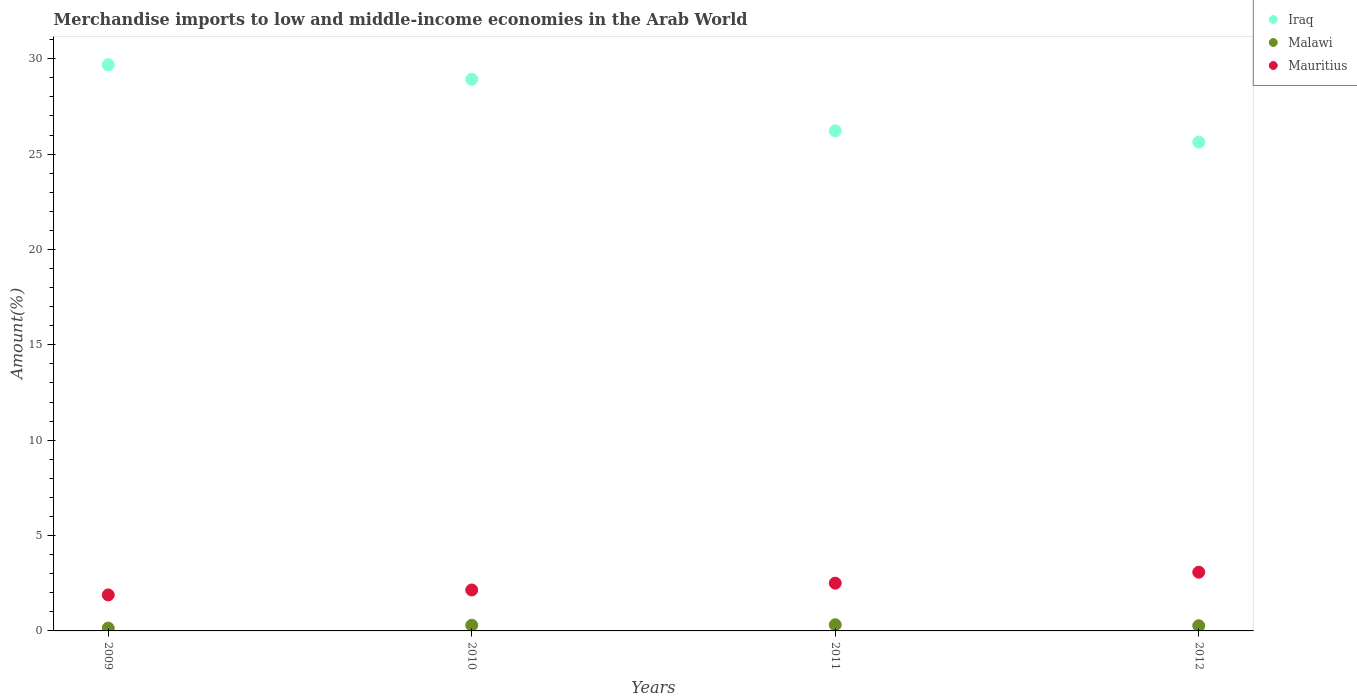Is the number of dotlines equal to the number of legend labels?
Make the answer very short. Yes. What is the percentage of amount earned from merchandise imports in Malawi in 2010?
Offer a very short reply. 0.3. Across all years, what is the maximum percentage of amount earned from merchandise imports in Mauritius?
Make the answer very short. 3.08. Across all years, what is the minimum percentage of amount earned from merchandise imports in Iraq?
Your response must be concise. 25.63. In which year was the percentage of amount earned from merchandise imports in Mauritius maximum?
Offer a very short reply. 2012. What is the total percentage of amount earned from merchandise imports in Malawi in the graph?
Your answer should be very brief. 1.04. What is the difference between the percentage of amount earned from merchandise imports in Malawi in 2009 and that in 2012?
Your response must be concise. -0.12. What is the difference between the percentage of amount earned from merchandise imports in Mauritius in 2011 and the percentage of amount earned from merchandise imports in Iraq in 2010?
Your answer should be compact. -26.41. What is the average percentage of amount earned from merchandise imports in Iraq per year?
Offer a very short reply. 27.61. In the year 2011, what is the difference between the percentage of amount earned from merchandise imports in Malawi and percentage of amount earned from merchandise imports in Iraq?
Your answer should be compact. -25.9. In how many years, is the percentage of amount earned from merchandise imports in Mauritius greater than 20 %?
Your answer should be very brief. 0. What is the ratio of the percentage of amount earned from merchandise imports in Malawi in 2011 to that in 2012?
Your response must be concise. 1.2. Is the percentage of amount earned from merchandise imports in Malawi in 2009 less than that in 2010?
Provide a short and direct response. Yes. What is the difference between the highest and the second highest percentage of amount earned from merchandise imports in Malawi?
Offer a very short reply. 0.03. What is the difference between the highest and the lowest percentage of amount earned from merchandise imports in Iraq?
Your answer should be compact. 4.05. Is the sum of the percentage of amount earned from merchandise imports in Mauritius in 2010 and 2011 greater than the maximum percentage of amount earned from merchandise imports in Iraq across all years?
Provide a succinct answer. No. Is it the case that in every year, the sum of the percentage of amount earned from merchandise imports in Iraq and percentage of amount earned from merchandise imports in Malawi  is greater than the percentage of amount earned from merchandise imports in Mauritius?
Your answer should be very brief. Yes. Does the percentage of amount earned from merchandise imports in Malawi monotonically increase over the years?
Make the answer very short. No. Is the percentage of amount earned from merchandise imports in Mauritius strictly greater than the percentage of amount earned from merchandise imports in Malawi over the years?
Your answer should be compact. Yes. Is the percentage of amount earned from merchandise imports in Iraq strictly less than the percentage of amount earned from merchandise imports in Malawi over the years?
Your answer should be very brief. No. How many years are there in the graph?
Keep it short and to the point. 4. What is the difference between two consecutive major ticks on the Y-axis?
Ensure brevity in your answer.  5. Are the values on the major ticks of Y-axis written in scientific E-notation?
Offer a very short reply. No. Does the graph contain any zero values?
Provide a short and direct response. No. Where does the legend appear in the graph?
Ensure brevity in your answer.  Top right. How many legend labels are there?
Keep it short and to the point. 3. What is the title of the graph?
Your response must be concise. Merchandise imports to low and middle-income economies in the Arab World. Does "Low income" appear as one of the legend labels in the graph?
Make the answer very short. No. What is the label or title of the X-axis?
Keep it short and to the point. Years. What is the label or title of the Y-axis?
Your answer should be compact. Amount(%). What is the Amount(%) of Iraq in 2009?
Your answer should be very brief. 29.68. What is the Amount(%) of Malawi in 2009?
Make the answer very short. 0.15. What is the Amount(%) in Mauritius in 2009?
Your answer should be compact. 1.89. What is the Amount(%) in Iraq in 2010?
Your answer should be very brief. 28.92. What is the Amount(%) in Malawi in 2010?
Ensure brevity in your answer.  0.3. What is the Amount(%) of Mauritius in 2010?
Offer a terse response. 2.15. What is the Amount(%) in Iraq in 2011?
Keep it short and to the point. 26.22. What is the Amount(%) of Malawi in 2011?
Keep it short and to the point. 0.32. What is the Amount(%) of Mauritius in 2011?
Ensure brevity in your answer.  2.5. What is the Amount(%) in Iraq in 2012?
Provide a short and direct response. 25.63. What is the Amount(%) in Malawi in 2012?
Offer a terse response. 0.27. What is the Amount(%) in Mauritius in 2012?
Ensure brevity in your answer.  3.08. Across all years, what is the maximum Amount(%) in Iraq?
Provide a succinct answer. 29.68. Across all years, what is the maximum Amount(%) in Malawi?
Your response must be concise. 0.32. Across all years, what is the maximum Amount(%) in Mauritius?
Your answer should be very brief. 3.08. Across all years, what is the minimum Amount(%) of Iraq?
Provide a succinct answer. 25.63. Across all years, what is the minimum Amount(%) in Malawi?
Ensure brevity in your answer.  0.15. Across all years, what is the minimum Amount(%) of Mauritius?
Provide a short and direct response. 1.89. What is the total Amount(%) in Iraq in the graph?
Offer a very short reply. 110.45. What is the total Amount(%) in Mauritius in the graph?
Provide a succinct answer. 9.62. What is the difference between the Amount(%) of Iraq in 2009 and that in 2010?
Your answer should be compact. 0.77. What is the difference between the Amount(%) of Malawi in 2009 and that in 2010?
Keep it short and to the point. -0.15. What is the difference between the Amount(%) of Mauritius in 2009 and that in 2010?
Your answer should be compact. -0.26. What is the difference between the Amount(%) of Iraq in 2009 and that in 2011?
Give a very brief answer. 3.46. What is the difference between the Amount(%) of Malawi in 2009 and that in 2011?
Provide a succinct answer. -0.18. What is the difference between the Amount(%) in Mauritius in 2009 and that in 2011?
Your answer should be compact. -0.62. What is the difference between the Amount(%) of Iraq in 2009 and that in 2012?
Your answer should be very brief. 4.05. What is the difference between the Amount(%) in Malawi in 2009 and that in 2012?
Offer a very short reply. -0.12. What is the difference between the Amount(%) in Mauritius in 2009 and that in 2012?
Offer a very short reply. -1.19. What is the difference between the Amount(%) of Iraq in 2010 and that in 2011?
Your response must be concise. 2.7. What is the difference between the Amount(%) of Malawi in 2010 and that in 2011?
Give a very brief answer. -0.03. What is the difference between the Amount(%) in Mauritius in 2010 and that in 2011?
Your answer should be very brief. -0.36. What is the difference between the Amount(%) of Iraq in 2010 and that in 2012?
Offer a very short reply. 3.29. What is the difference between the Amount(%) of Malawi in 2010 and that in 2012?
Provide a succinct answer. 0.03. What is the difference between the Amount(%) in Mauritius in 2010 and that in 2012?
Make the answer very short. -0.93. What is the difference between the Amount(%) of Iraq in 2011 and that in 2012?
Your response must be concise. 0.59. What is the difference between the Amount(%) in Malawi in 2011 and that in 2012?
Offer a terse response. 0.05. What is the difference between the Amount(%) of Mauritius in 2011 and that in 2012?
Ensure brevity in your answer.  -0.57. What is the difference between the Amount(%) of Iraq in 2009 and the Amount(%) of Malawi in 2010?
Your response must be concise. 29.39. What is the difference between the Amount(%) of Iraq in 2009 and the Amount(%) of Mauritius in 2010?
Offer a terse response. 27.54. What is the difference between the Amount(%) of Malawi in 2009 and the Amount(%) of Mauritius in 2010?
Give a very brief answer. -2. What is the difference between the Amount(%) in Iraq in 2009 and the Amount(%) in Malawi in 2011?
Your answer should be compact. 29.36. What is the difference between the Amount(%) in Iraq in 2009 and the Amount(%) in Mauritius in 2011?
Offer a very short reply. 27.18. What is the difference between the Amount(%) in Malawi in 2009 and the Amount(%) in Mauritius in 2011?
Ensure brevity in your answer.  -2.36. What is the difference between the Amount(%) in Iraq in 2009 and the Amount(%) in Malawi in 2012?
Your answer should be very brief. 29.41. What is the difference between the Amount(%) in Iraq in 2009 and the Amount(%) in Mauritius in 2012?
Offer a very short reply. 26.61. What is the difference between the Amount(%) in Malawi in 2009 and the Amount(%) in Mauritius in 2012?
Provide a short and direct response. -2.93. What is the difference between the Amount(%) of Iraq in 2010 and the Amount(%) of Malawi in 2011?
Your answer should be very brief. 28.59. What is the difference between the Amount(%) in Iraq in 2010 and the Amount(%) in Mauritius in 2011?
Keep it short and to the point. 26.41. What is the difference between the Amount(%) of Malawi in 2010 and the Amount(%) of Mauritius in 2011?
Your response must be concise. -2.21. What is the difference between the Amount(%) of Iraq in 2010 and the Amount(%) of Malawi in 2012?
Provide a succinct answer. 28.65. What is the difference between the Amount(%) of Iraq in 2010 and the Amount(%) of Mauritius in 2012?
Offer a very short reply. 25.84. What is the difference between the Amount(%) of Malawi in 2010 and the Amount(%) of Mauritius in 2012?
Your response must be concise. -2.78. What is the difference between the Amount(%) in Iraq in 2011 and the Amount(%) in Malawi in 2012?
Make the answer very short. 25.95. What is the difference between the Amount(%) of Iraq in 2011 and the Amount(%) of Mauritius in 2012?
Make the answer very short. 23.14. What is the difference between the Amount(%) in Malawi in 2011 and the Amount(%) in Mauritius in 2012?
Your answer should be very brief. -2.75. What is the average Amount(%) of Iraq per year?
Keep it short and to the point. 27.61. What is the average Amount(%) in Malawi per year?
Provide a short and direct response. 0.26. What is the average Amount(%) of Mauritius per year?
Offer a very short reply. 2.4. In the year 2009, what is the difference between the Amount(%) in Iraq and Amount(%) in Malawi?
Keep it short and to the point. 29.54. In the year 2009, what is the difference between the Amount(%) of Iraq and Amount(%) of Mauritius?
Provide a short and direct response. 27.8. In the year 2009, what is the difference between the Amount(%) in Malawi and Amount(%) in Mauritius?
Your response must be concise. -1.74. In the year 2010, what is the difference between the Amount(%) in Iraq and Amount(%) in Malawi?
Provide a succinct answer. 28.62. In the year 2010, what is the difference between the Amount(%) of Iraq and Amount(%) of Mauritius?
Your response must be concise. 26.77. In the year 2010, what is the difference between the Amount(%) in Malawi and Amount(%) in Mauritius?
Your answer should be very brief. -1.85. In the year 2011, what is the difference between the Amount(%) of Iraq and Amount(%) of Malawi?
Give a very brief answer. 25.9. In the year 2011, what is the difference between the Amount(%) of Iraq and Amount(%) of Mauritius?
Your answer should be compact. 23.72. In the year 2011, what is the difference between the Amount(%) in Malawi and Amount(%) in Mauritius?
Make the answer very short. -2.18. In the year 2012, what is the difference between the Amount(%) in Iraq and Amount(%) in Malawi?
Give a very brief answer. 25.36. In the year 2012, what is the difference between the Amount(%) of Iraq and Amount(%) of Mauritius?
Your answer should be compact. 22.55. In the year 2012, what is the difference between the Amount(%) of Malawi and Amount(%) of Mauritius?
Your response must be concise. -2.81. What is the ratio of the Amount(%) of Iraq in 2009 to that in 2010?
Your response must be concise. 1.03. What is the ratio of the Amount(%) of Malawi in 2009 to that in 2010?
Your answer should be compact. 0.5. What is the ratio of the Amount(%) of Mauritius in 2009 to that in 2010?
Your answer should be very brief. 0.88. What is the ratio of the Amount(%) in Iraq in 2009 to that in 2011?
Give a very brief answer. 1.13. What is the ratio of the Amount(%) of Malawi in 2009 to that in 2011?
Your answer should be very brief. 0.46. What is the ratio of the Amount(%) in Mauritius in 2009 to that in 2011?
Make the answer very short. 0.75. What is the ratio of the Amount(%) of Iraq in 2009 to that in 2012?
Your response must be concise. 1.16. What is the ratio of the Amount(%) of Malawi in 2009 to that in 2012?
Your answer should be very brief. 0.55. What is the ratio of the Amount(%) in Mauritius in 2009 to that in 2012?
Give a very brief answer. 0.61. What is the ratio of the Amount(%) in Iraq in 2010 to that in 2011?
Provide a succinct answer. 1.1. What is the ratio of the Amount(%) of Malawi in 2010 to that in 2011?
Offer a very short reply. 0.91. What is the ratio of the Amount(%) in Mauritius in 2010 to that in 2011?
Ensure brevity in your answer.  0.86. What is the ratio of the Amount(%) of Iraq in 2010 to that in 2012?
Offer a very short reply. 1.13. What is the ratio of the Amount(%) in Malawi in 2010 to that in 2012?
Offer a very short reply. 1.09. What is the ratio of the Amount(%) in Mauritius in 2010 to that in 2012?
Your answer should be very brief. 0.7. What is the ratio of the Amount(%) of Iraq in 2011 to that in 2012?
Keep it short and to the point. 1.02. What is the ratio of the Amount(%) in Malawi in 2011 to that in 2012?
Make the answer very short. 1.2. What is the ratio of the Amount(%) of Mauritius in 2011 to that in 2012?
Your answer should be compact. 0.81. What is the difference between the highest and the second highest Amount(%) in Iraq?
Your answer should be compact. 0.77. What is the difference between the highest and the second highest Amount(%) in Malawi?
Keep it short and to the point. 0.03. What is the difference between the highest and the second highest Amount(%) of Mauritius?
Your answer should be compact. 0.57. What is the difference between the highest and the lowest Amount(%) of Iraq?
Your response must be concise. 4.05. What is the difference between the highest and the lowest Amount(%) in Malawi?
Make the answer very short. 0.18. What is the difference between the highest and the lowest Amount(%) in Mauritius?
Provide a short and direct response. 1.19. 